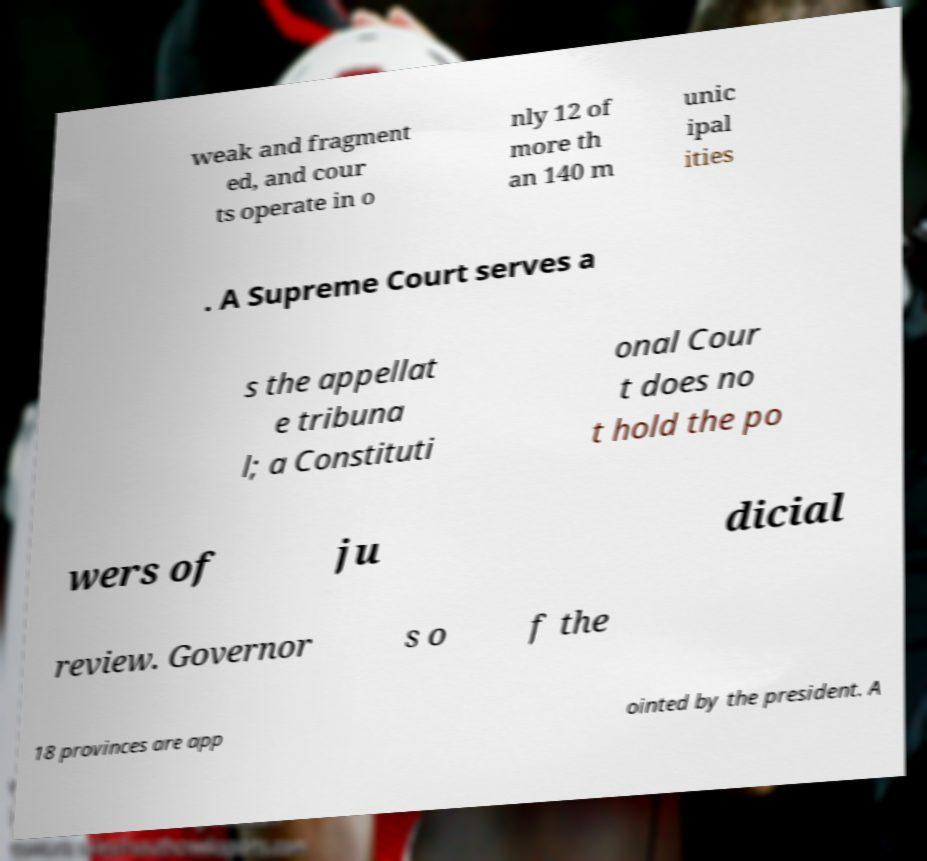Please identify and transcribe the text found in this image. weak and fragment ed, and cour ts operate in o nly 12 of more th an 140 m unic ipal ities . A Supreme Court serves a s the appellat e tribuna l; a Constituti onal Cour t does no t hold the po wers of ju dicial review. Governor s o f the 18 provinces are app ointed by the president. A 